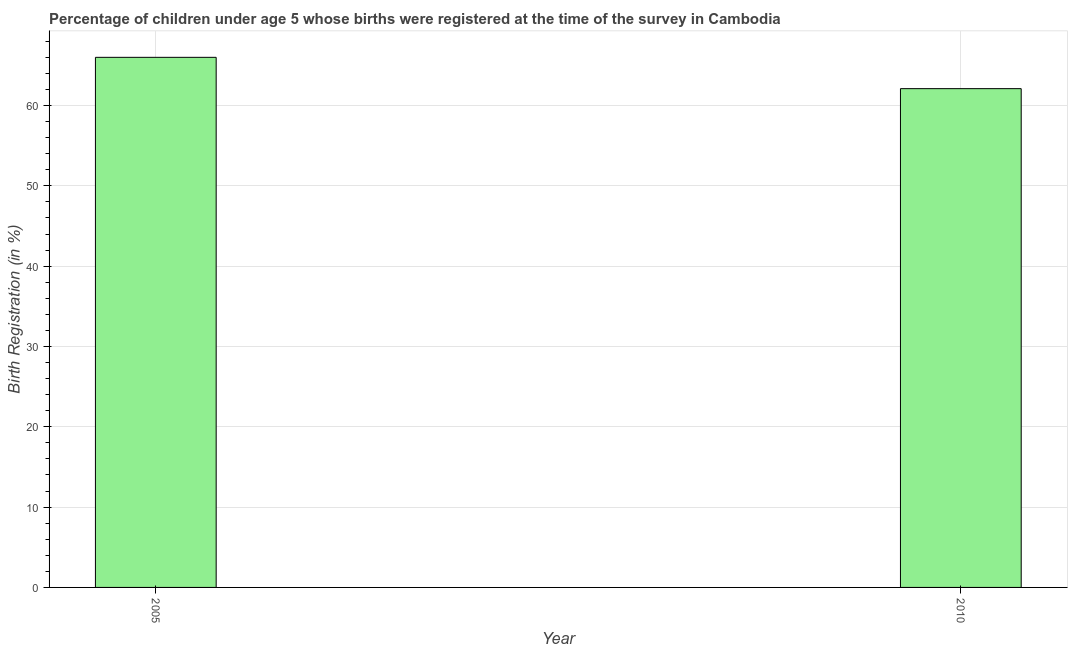Does the graph contain any zero values?
Make the answer very short. No. What is the title of the graph?
Offer a terse response. Percentage of children under age 5 whose births were registered at the time of the survey in Cambodia. What is the label or title of the X-axis?
Offer a terse response. Year. What is the label or title of the Y-axis?
Make the answer very short. Birth Registration (in %). Across all years, what is the minimum birth registration?
Keep it short and to the point. 62.1. In which year was the birth registration minimum?
Your answer should be very brief. 2010. What is the sum of the birth registration?
Provide a short and direct response. 128.1. What is the difference between the birth registration in 2005 and 2010?
Your answer should be very brief. 3.9. What is the average birth registration per year?
Your answer should be very brief. 64.05. What is the median birth registration?
Give a very brief answer. 64.05. What is the ratio of the birth registration in 2005 to that in 2010?
Ensure brevity in your answer.  1.06. Is the birth registration in 2005 less than that in 2010?
Provide a succinct answer. No. How many years are there in the graph?
Make the answer very short. 2. Are the values on the major ticks of Y-axis written in scientific E-notation?
Make the answer very short. No. What is the Birth Registration (in %) in 2005?
Provide a short and direct response. 66. What is the Birth Registration (in %) in 2010?
Provide a succinct answer. 62.1. What is the ratio of the Birth Registration (in %) in 2005 to that in 2010?
Your response must be concise. 1.06. 